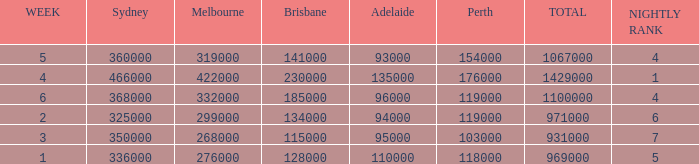What was the rating for Brisbane the week that Adelaide had 94000? 134000.0. 